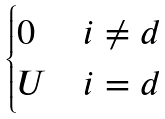Convert formula to latex. <formula><loc_0><loc_0><loc_500><loc_500>\begin{cases} 0 & i \neq d \\ U & i = d \end{cases}</formula> 